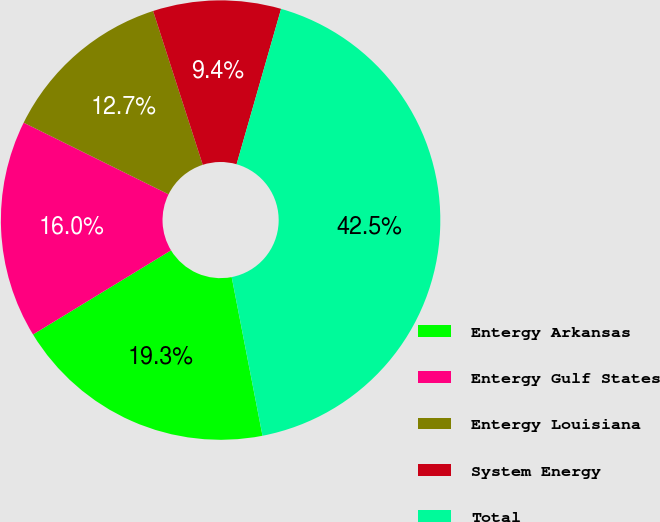Convert chart. <chart><loc_0><loc_0><loc_500><loc_500><pie_chart><fcel>Entergy Arkansas<fcel>Entergy Gulf States<fcel>Entergy Louisiana<fcel>System Energy<fcel>Total<nl><fcel>19.34%<fcel>16.03%<fcel>12.72%<fcel>9.41%<fcel>42.51%<nl></chart> 